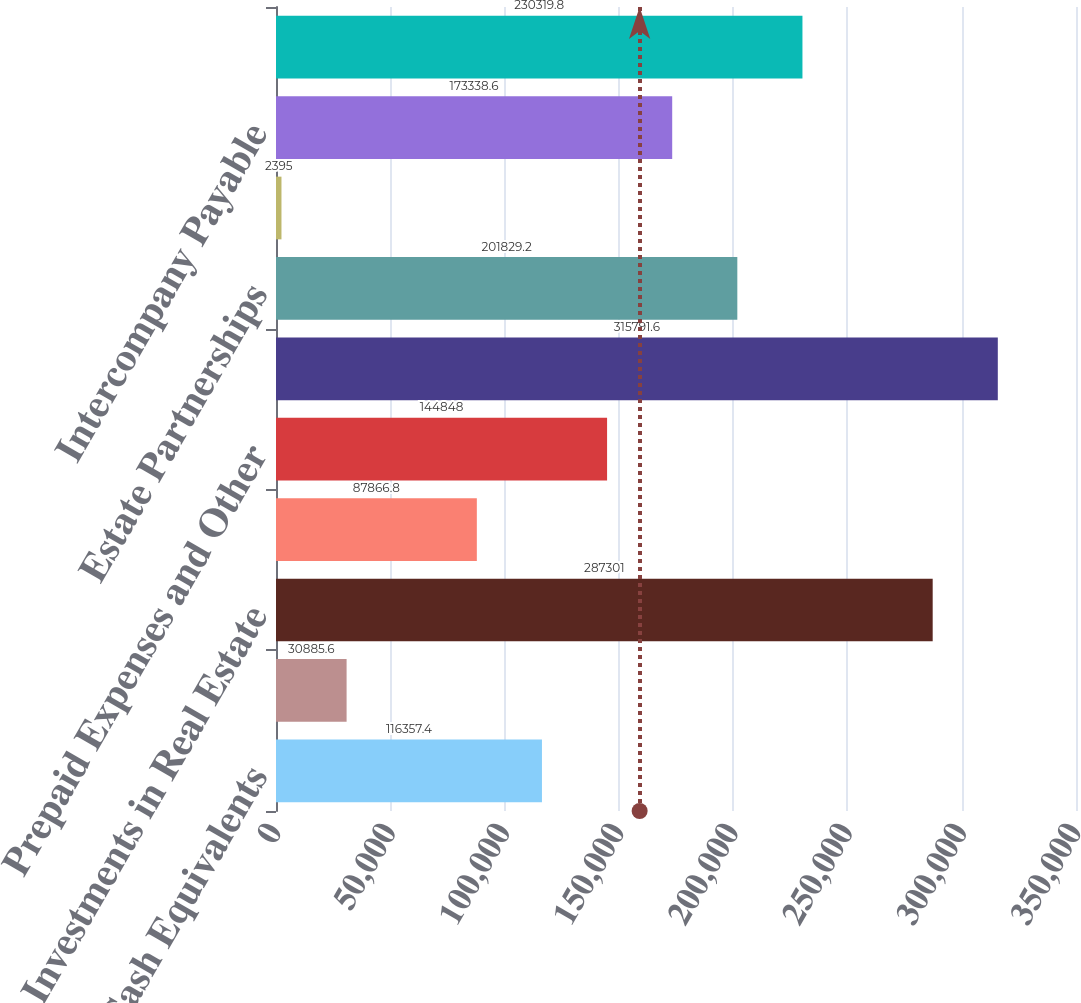Convert chart. <chart><loc_0><loc_0><loc_500><loc_500><bar_chart><fcel>Cash and Cash Equivalents<fcel>Receivables Other<fcel>Investments in Real Estate<fcel>Trust Fund Investment in<fcel>Prepaid Expenses and Other<fcel>Total Assets<fcel>Estate Partnerships<fcel>Trade and Other Payable<fcel>Intercompany Payable<fcel>Total Liabilities<nl><fcel>116357<fcel>30885.6<fcel>287301<fcel>87866.8<fcel>144848<fcel>315792<fcel>201829<fcel>2395<fcel>173339<fcel>230320<nl></chart> 